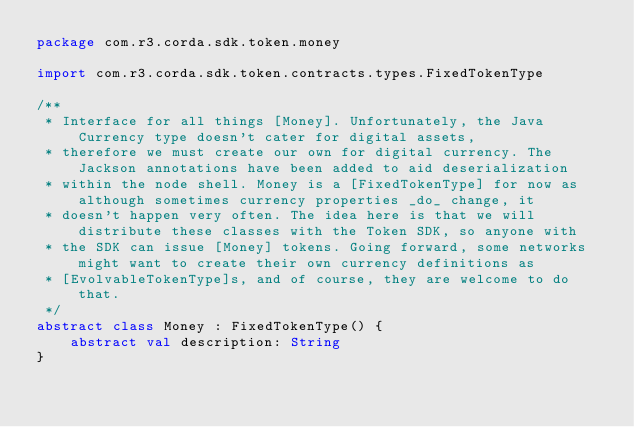<code> <loc_0><loc_0><loc_500><loc_500><_Kotlin_>package com.r3.corda.sdk.token.money

import com.r3.corda.sdk.token.contracts.types.FixedTokenType

/**
 * Interface for all things [Money]. Unfortunately, the Java Currency type doesn't cater for digital assets,
 * therefore we must create our own for digital currency. The Jackson annotations have been added to aid deserialization
 * within the node shell. Money is a [FixedTokenType] for now as although sometimes currency properties _do_ change, it
 * doesn't happen very often. The idea here is that we will distribute these classes with the Token SDK, so anyone with
 * the SDK can issue [Money] tokens. Going forward, some networks might want to create their own currency definitions as
 * [EvolvableTokenType]s, and of course, they are welcome to do that.
 */
abstract class Money : FixedTokenType() {
    abstract val description: String
}



</code> 